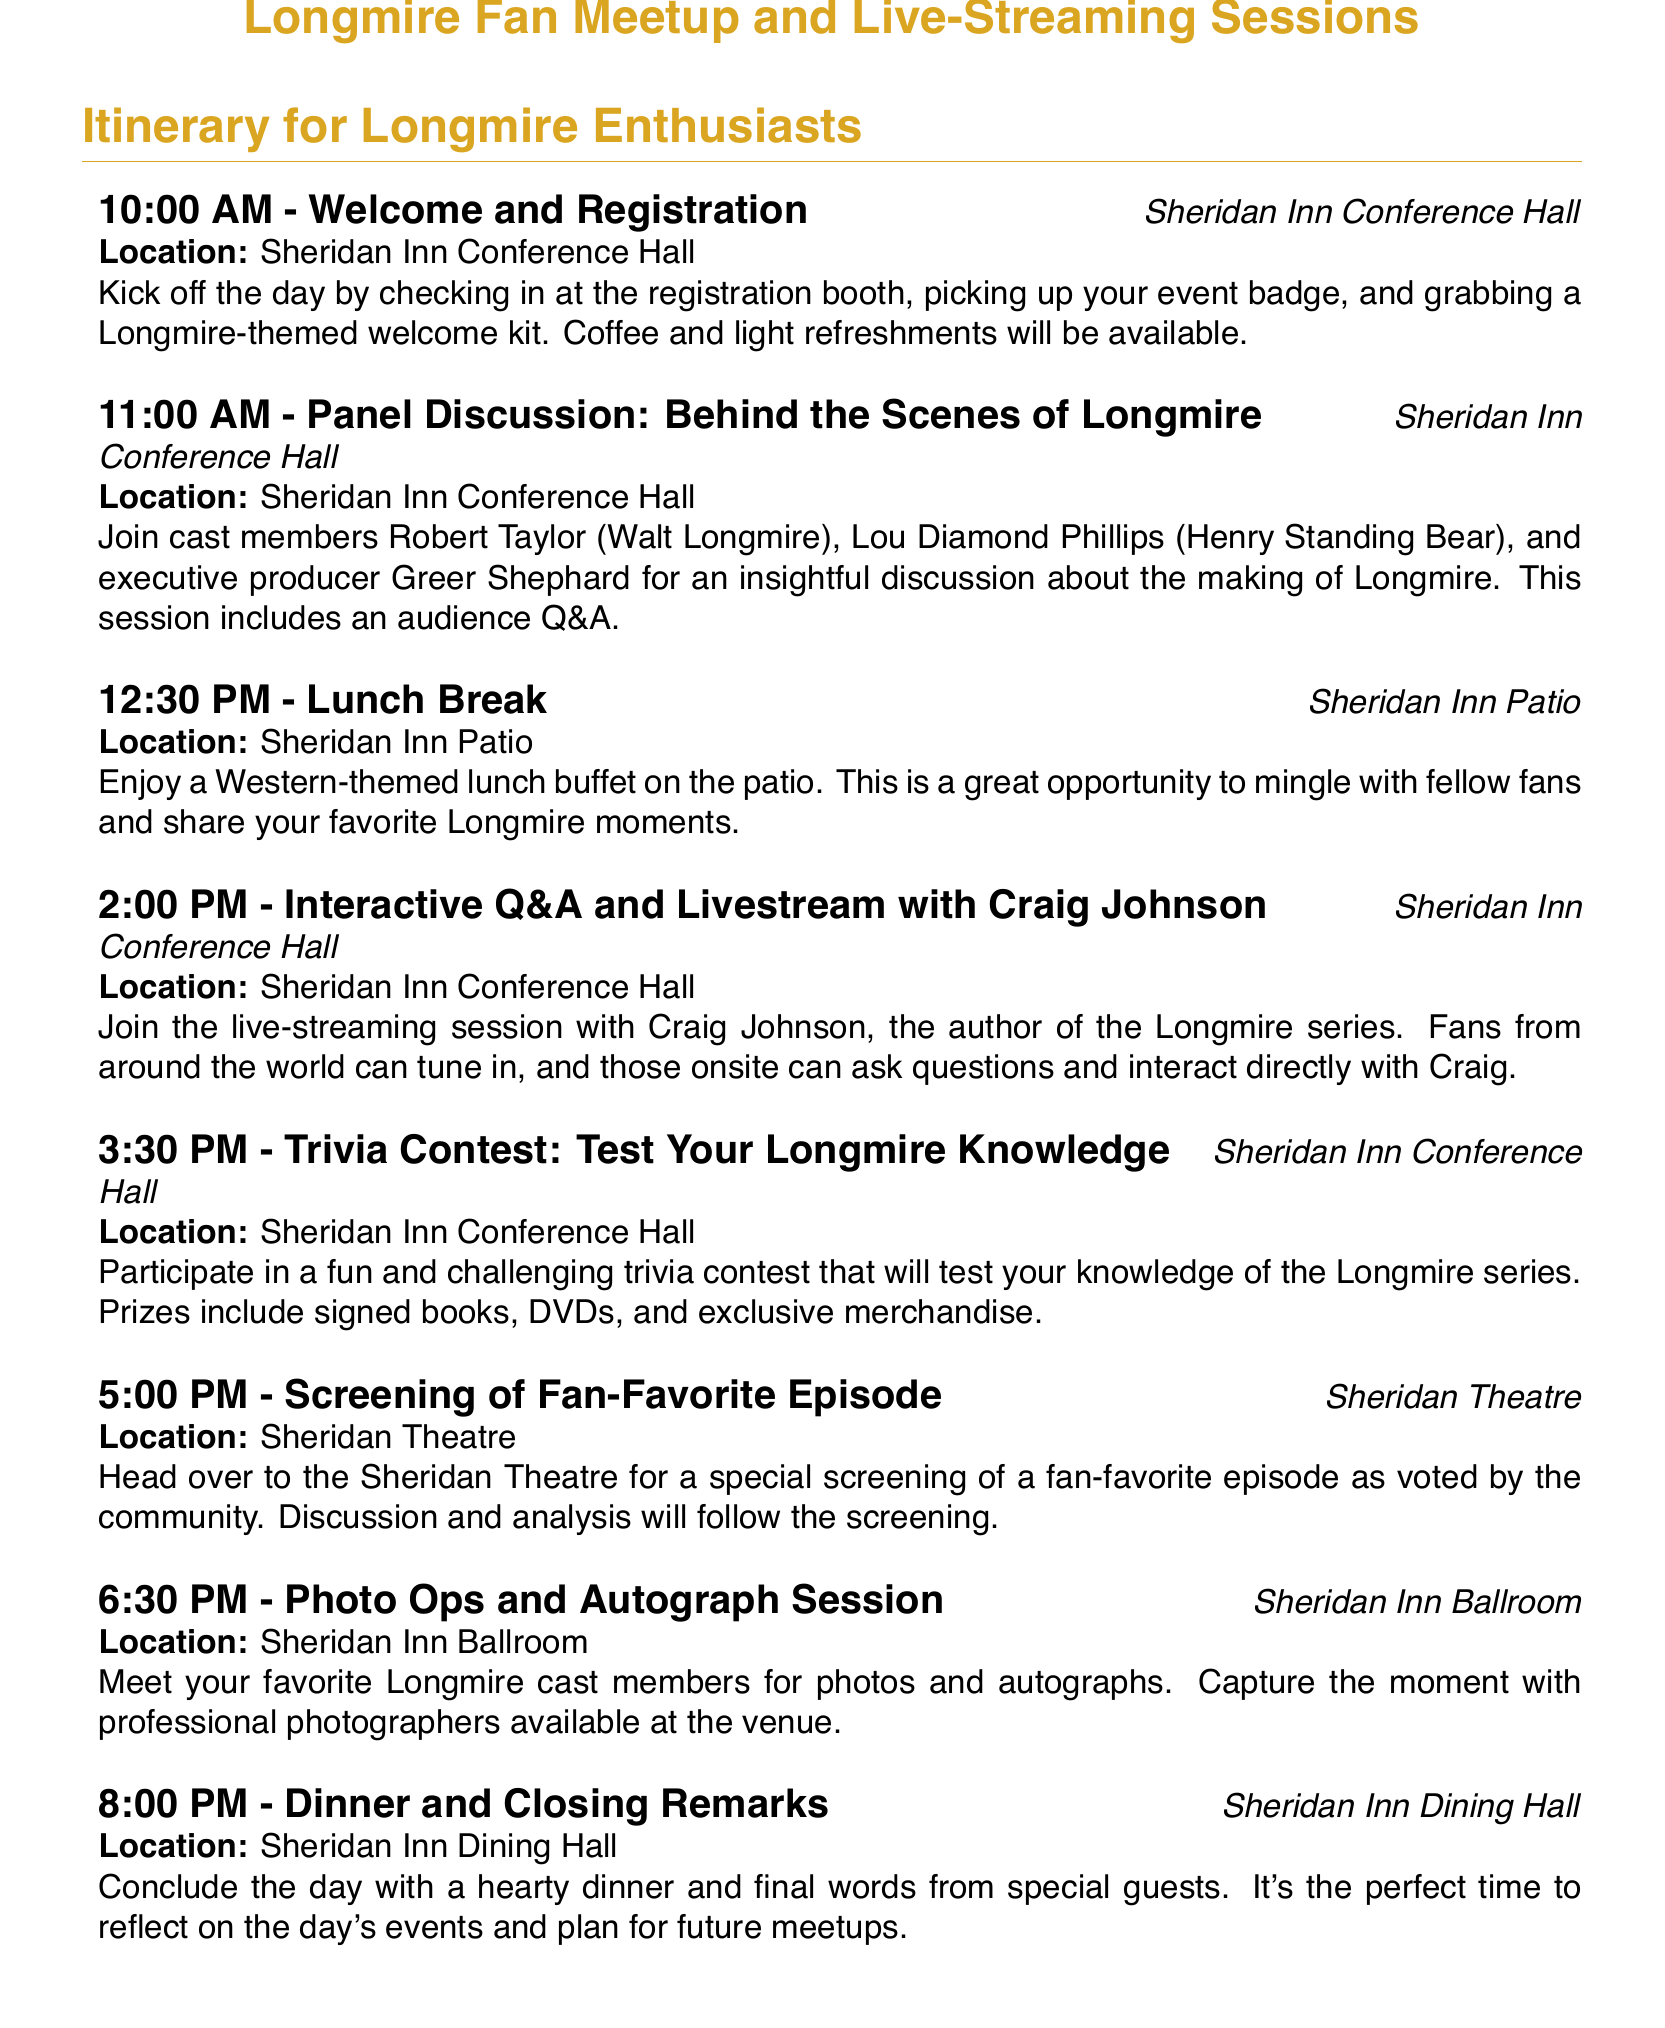What time does the event start? The event starts at 10:00 AM as mentioned in the first item of the itinerary.
Answer: 10:00 AM Who is the executive producer participating in the panel discussion? The panel discussion includes executive producer Greer Shephard, as listed in the second item.
Answer: Greer Shephard Where is the lunch break scheduled? The lunch break is scheduled at Sheridan Inn Patio, found in the third item of the list.
Answer: Sheridan Inn Patio How long is the interactive Q&A and livestream session with Craig Johnson? The duration of the interactive Q&A and livestream session is implied to be from 2:00 PM to 3:30 PM, totaling 1.5 hours.
Answer: 1.5 hours What special event occurs at 5:00 PM? The special event at 5:00 PM is the screening of a fan-favorite episode according to the sixth item.
Answer: Screening of Fan-Favorite Episode What is the last activity of the day? The last activity listed in the itinerary is Dinner and Closing Remarks, as noted in the eighth item.
Answer: Dinner and Closing Remarks How many prizes are offered in the trivia contest? Specific details on the number of prizes are not mentioned, but it states prizes include signed books, DVDs, and exclusive merchandise, implying multiple.
Answer: Multiple What is provided at the registration booth? The registration booth provides a Longmire-themed welcome kit, mentioned in the first item.
Answer: Longmire-themed welcome kit What is the venue for the photo ops and autograph session? The venue for the photo ops and autograph session is the Sheridan Inn Ballroom, found in the seventh item.
Answer: Sheridan Inn Ballroom 